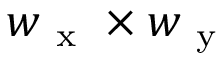<formula> <loc_0><loc_0><loc_500><loc_500>w _ { x } \times w _ { y }</formula> 